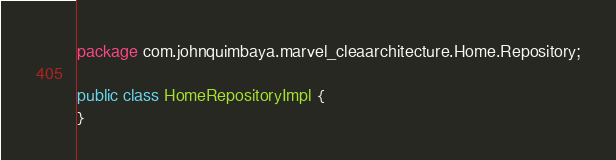<code> <loc_0><loc_0><loc_500><loc_500><_Java_>package com.johnquimbaya.marvel_cleaarchitecture.Home.Repository;

public class HomeRepositoryImpl {
}
</code> 